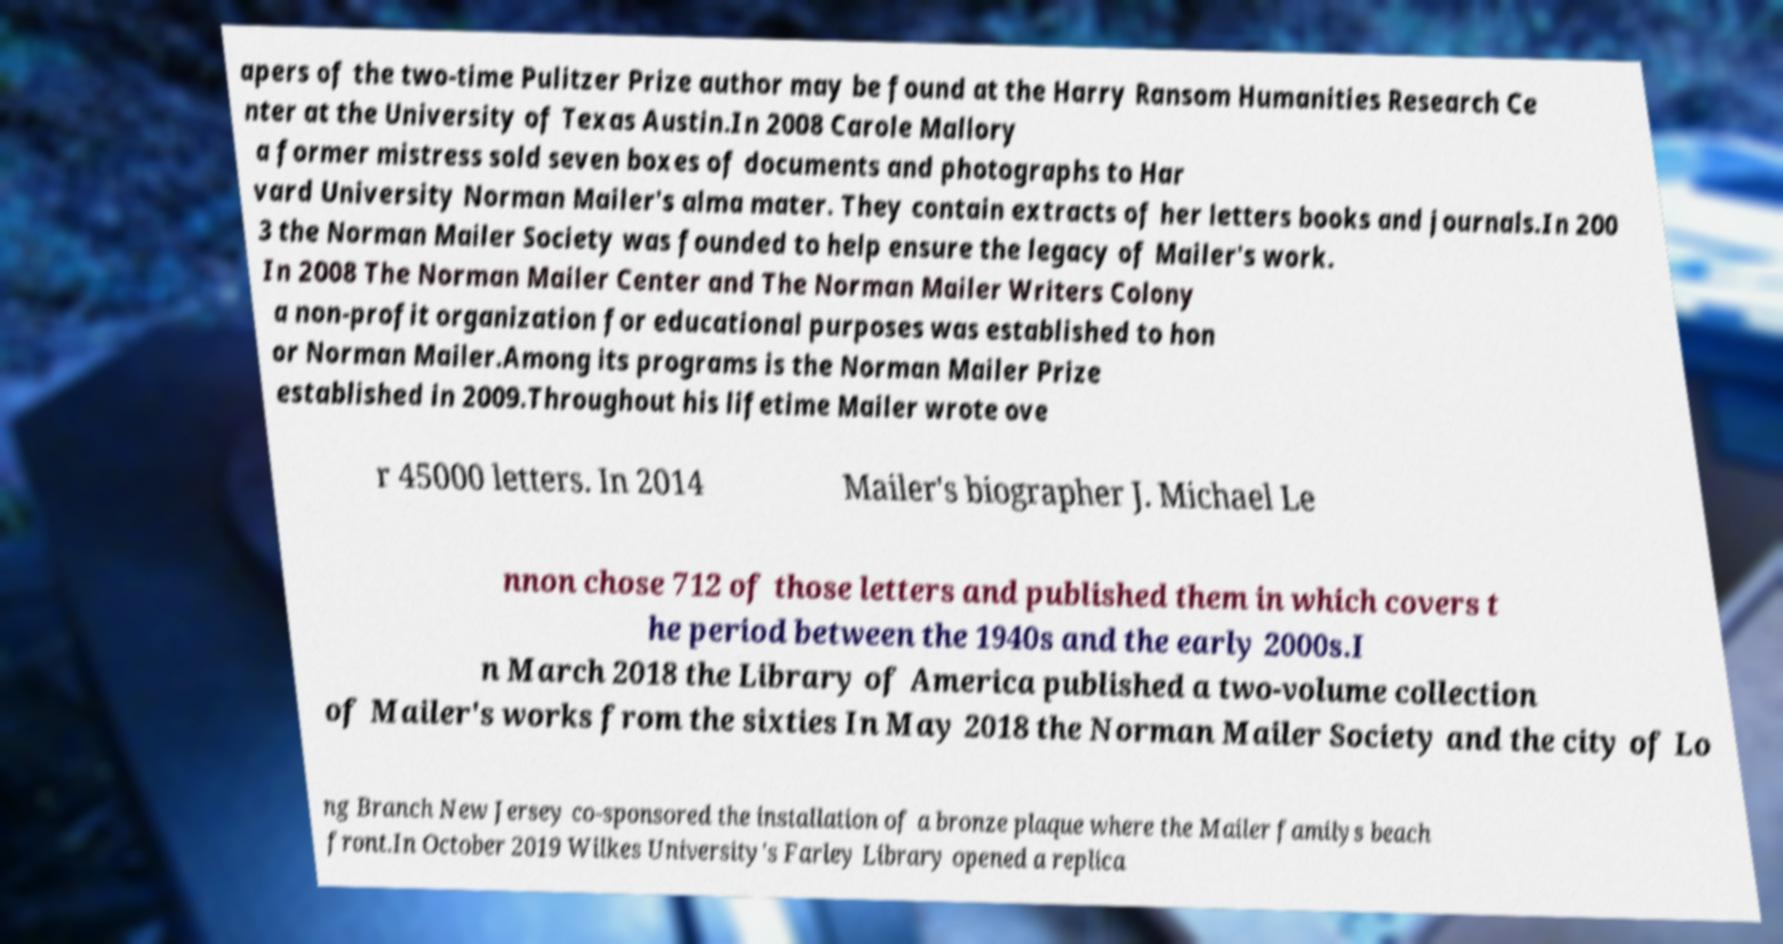What messages or text are displayed in this image? I need them in a readable, typed format. apers of the two-time Pulitzer Prize author may be found at the Harry Ransom Humanities Research Ce nter at the University of Texas Austin.In 2008 Carole Mallory a former mistress sold seven boxes of documents and photographs to Har vard University Norman Mailer's alma mater. They contain extracts of her letters books and journals.In 200 3 the Norman Mailer Society was founded to help ensure the legacy of Mailer's work. In 2008 The Norman Mailer Center and The Norman Mailer Writers Colony a non-profit organization for educational purposes was established to hon or Norman Mailer.Among its programs is the Norman Mailer Prize established in 2009.Throughout his lifetime Mailer wrote ove r 45000 letters. In 2014 Mailer's biographer J. Michael Le nnon chose 712 of those letters and published them in which covers t he period between the 1940s and the early 2000s.I n March 2018 the Library of America published a two-volume collection of Mailer's works from the sixties In May 2018 the Norman Mailer Society and the city of Lo ng Branch New Jersey co-sponsored the installation of a bronze plaque where the Mailer familys beach front.In October 2019 Wilkes University's Farley Library opened a replica 